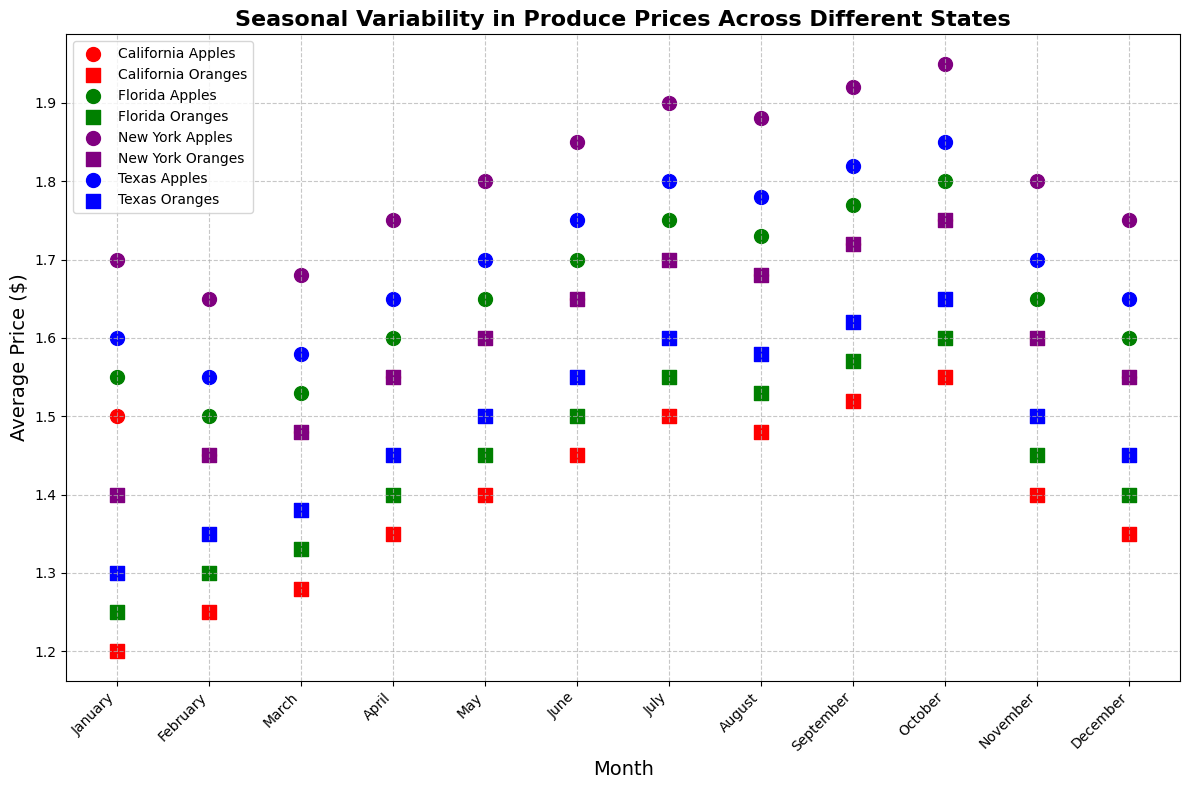What is the price range of apples in California throughout the year? To find the price range for apples in California, look at the minimum and maximum average price points on the scatter plot for apples marked by the color representing California. The minimum price is $1.45 (February) and the maximum price is $1.75 (October).
Answer: [$1.45, $1.75] How does the price of apples in New York in October compare to the price of oranges in California in the same month? Look for the data point representing apples in New York in October (purple circle) and oranges in California in October (red square). The price of apples in New York in October is $1.95 and the price of oranges in California in October is $1.55.
Answer: Apples in New York are $0.40 more expensive Which state has the most stable orange prices throughout the year? To determine stability, look for the state with the least variance (smallest spread) in the prices of oranges. By visually inspecting the scatter plot, note that California's orange prices (red squares) exhibit small fluctuations compared to other states.
Answer: California What is the general trend of apple prices in Texas from January to December? Observe the scatter plot for apples in Texas (blue circles). The prices start at $1.60 in January and rise steadily each month, peaking at $1.85 in October before decreasing slightly to $1.65 in December.
Answer: Increasing trend with a peak in October How do the average prices of oranges in Florida in July and August compare? Identify the points representing oranges in Florida (green squares) for July and August. The average price in July is $1.55 and in August is $1.53.
Answer: The price in August is $0.02 cheaper Which month shows the highest average price for apples across all states? Scan for the highest point among all apple data points across the graph. The highest price for apples is $1.95 in October in New York (purple circle).
Answer: October Is there a noticeable seasonal pattern in the price of oranges in Texas? Assess the scatter plot for oranges in Texas (blue squares) and observe if prices increase or decrease during specific months. The prices seem to increase until July ($1.60) and then slightly decrease moving into the last quarter of the year.
Answer: Yes, a rise until July followed by a slight decrease What is the average price difference between apples in Florida and apples in California in December? Compare the December prices of apples in both states: $1.60 (Florida) and $1.55 (California). Calculate the difference: $1.60 - $1.55.
Answer: $0.05 Which produce item in New York has a more substantial price increase from January to December? Look at the price difference between January and December for both apples (from $1.70 to $1.75) and oranges (from $1.40 to $1.55) in New York. The increase for apples is $0.05 while for oranges it is $0.15.
Answer: Oranges 